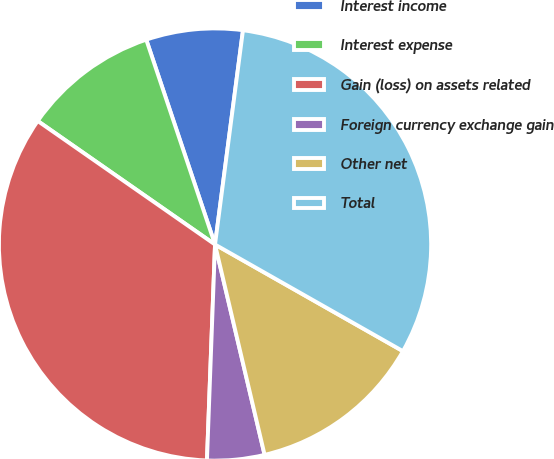Convert chart. <chart><loc_0><loc_0><loc_500><loc_500><pie_chart><fcel>Interest income<fcel>Interest expense<fcel>Gain (loss) on assets related<fcel>Foreign currency exchange gain<fcel>Other net<fcel>Total<nl><fcel>7.22%<fcel>10.16%<fcel>34.09%<fcel>4.28%<fcel>13.1%<fcel>31.15%<nl></chart> 